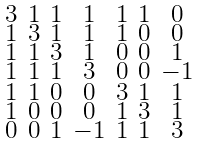Convert formula to latex. <formula><loc_0><loc_0><loc_500><loc_500>\begin{smallmatrix} 3 & 1 & 1 & 1 & 1 & 1 & 0 \\ 1 & 3 & 1 & 1 & 1 & 0 & 0 \\ 1 & 1 & 3 & 1 & 0 & 0 & 1 \\ 1 & 1 & 1 & 3 & 0 & 0 & - 1 \\ 1 & 1 & 0 & 0 & 3 & 1 & 1 \\ 1 & 0 & 0 & 0 & 1 & 3 & 1 \\ 0 & 0 & 1 & - 1 & 1 & 1 & 3 \end{smallmatrix}</formula> 